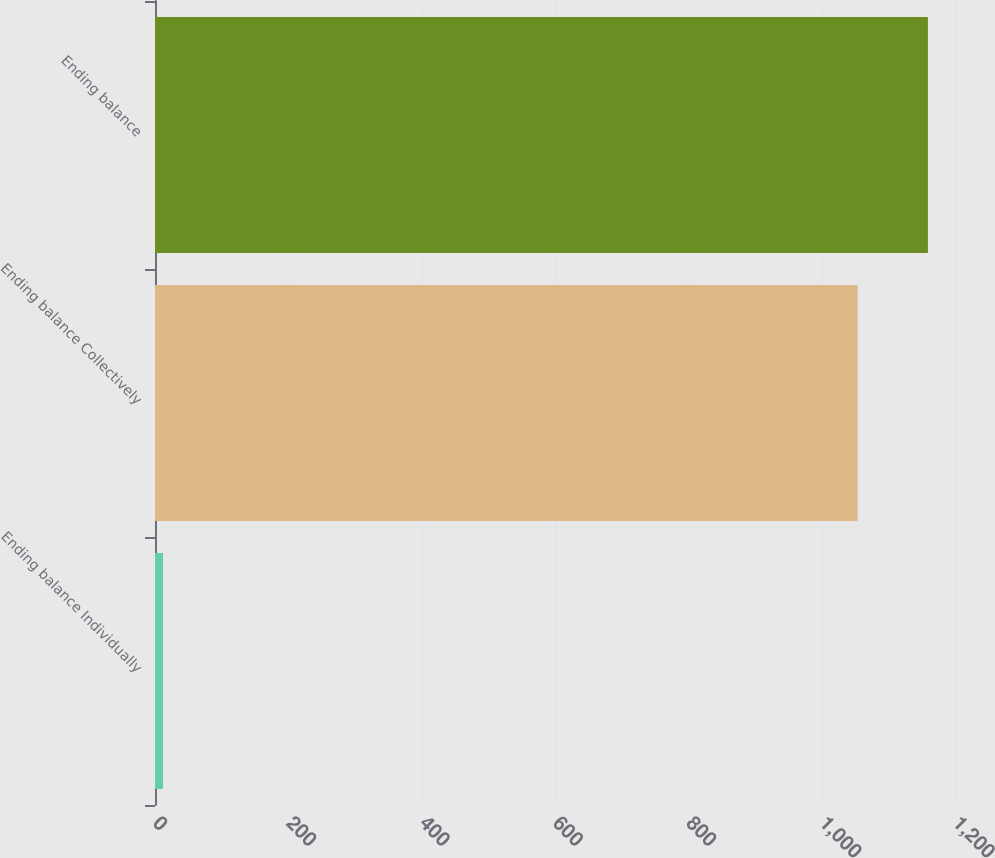Convert chart to OTSL. <chart><loc_0><loc_0><loc_500><loc_500><bar_chart><fcel>Ending balance Individually<fcel>Ending balance Collectively<fcel>Ending balance<nl><fcel>12<fcel>1054<fcel>1159.4<nl></chart> 